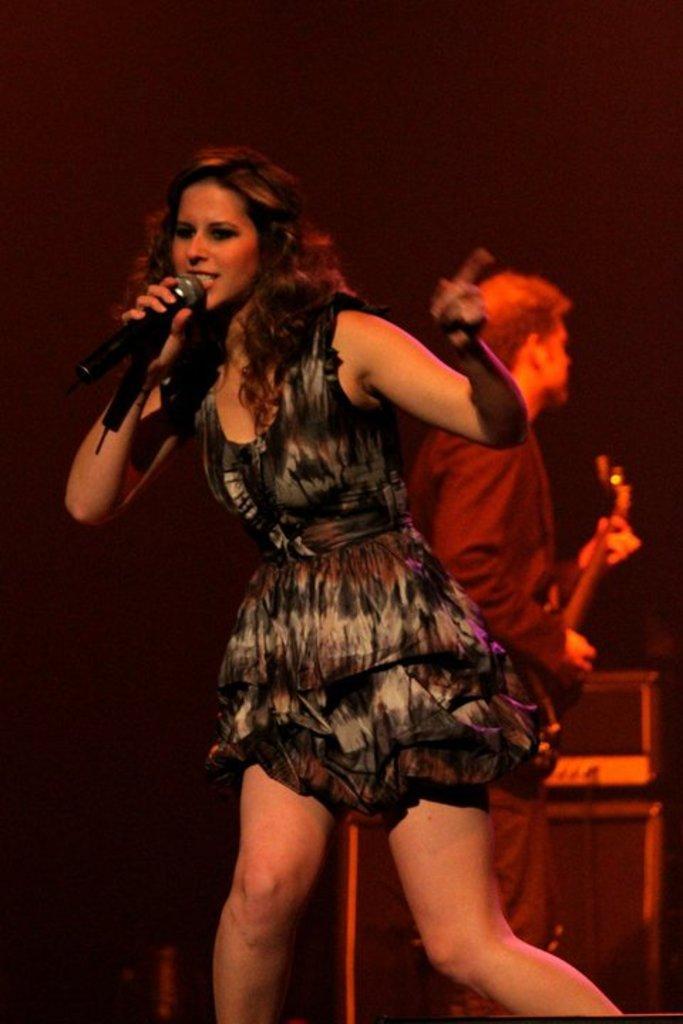Please provide a concise description of this image. In the center we can see one woman holding microphone. And back we can see one man holding guitar. 